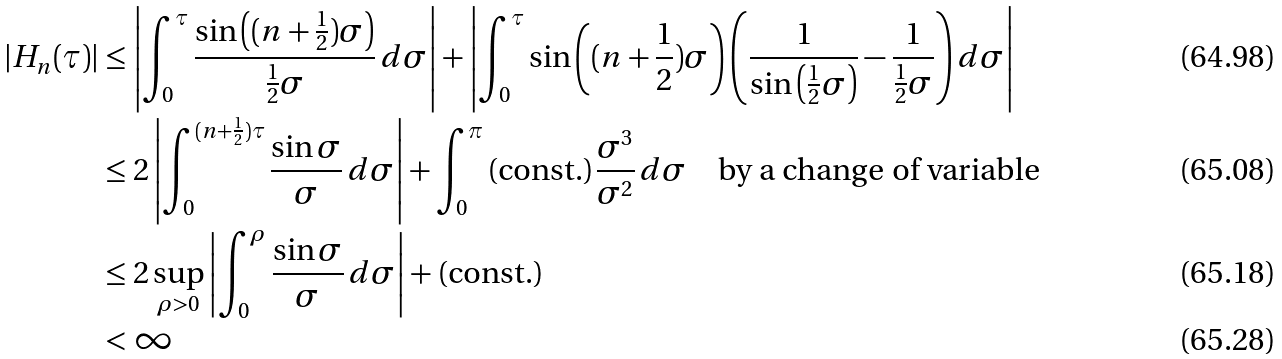Convert formula to latex. <formula><loc_0><loc_0><loc_500><loc_500>| H _ { n } ( \tau ) | & \leq \left | \int _ { 0 } ^ { \tau } \frac { \sin \left ( ( n + \frac { 1 } { 2 } ) \sigma \right ) } { \frac { 1 } { 2 } \sigma } \, d \sigma \right | + \left | \int _ { 0 } ^ { \tau } \sin \left ( ( n + \frac { 1 } { 2 } ) \sigma \right ) \left ( \frac { 1 } { \sin \left ( \frac { 1 } { 2 } \sigma \right ) } - \frac { 1 } { \frac { 1 } { 2 } \sigma } \right ) d \sigma \right | \\ & \leq 2 \left | \int _ { 0 } ^ { ( n + \frac { 1 } { 2 } ) \tau } \frac { \sin \sigma } { \sigma } \, d \sigma \right | + \int _ { 0 } ^ { \pi } \text {(const.)} \frac { \sigma ^ { 3 } } { \sigma ^ { 2 } } \, d \sigma \quad \text {by a change of variable} \\ & \leq 2 \sup _ { \rho > 0 } \left | \int _ { 0 } ^ { \rho } \frac { \sin \sigma } { \sigma } \, d \sigma \right | + \text {(const.)} \\ & < \infty</formula> 